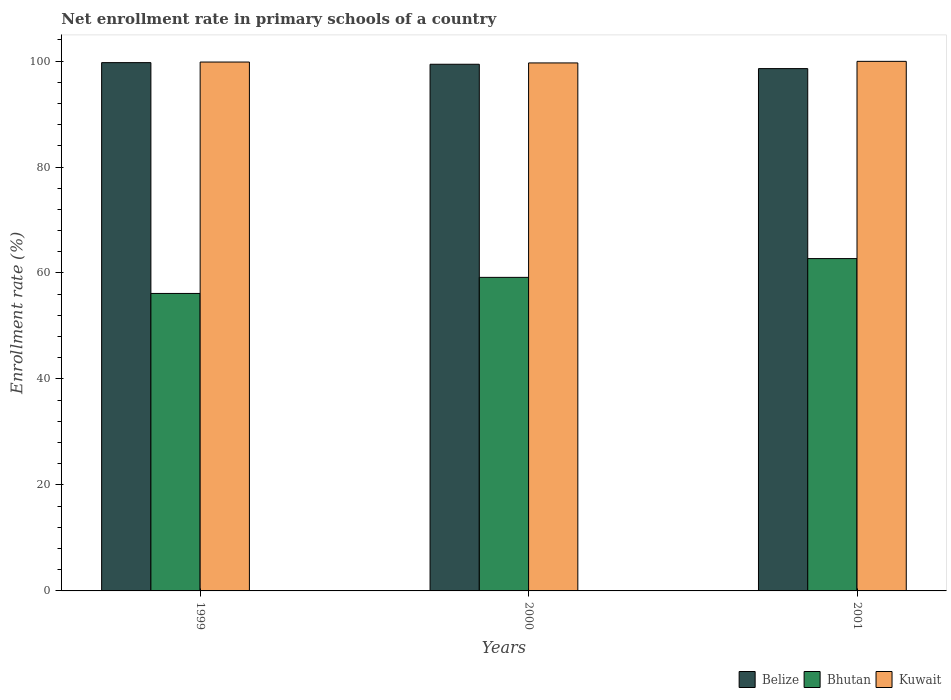How many different coloured bars are there?
Your answer should be very brief. 3. How many groups of bars are there?
Make the answer very short. 3. Are the number of bars on each tick of the X-axis equal?
Provide a succinct answer. Yes. In how many cases, is the number of bars for a given year not equal to the number of legend labels?
Provide a succinct answer. 0. What is the enrollment rate in primary schools in Kuwait in 2001?
Your answer should be very brief. 99.94. Across all years, what is the maximum enrollment rate in primary schools in Kuwait?
Make the answer very short. 99.94. Across all years, what is the minimum enrollment rate in primary schools in Belize?
Provide a succinct answer. 98.57. What is the total enrollment rate in primary schools in Bhutan in the graph?
Keep it short and to the point. 178.03. What is the difference between the enrollment rate in primary schools in Bhutan in 1999 and that in 2001?
Provide a succinct answer. -6.58. What is the difference between the enrollment rate in primary schools in Belize in 2001 and the enrollment rate in primary schools in Kuwait in 1999?
Your response must be concise. -1.24. What is the average enrollment rate in primary schools in Bhutan per year?
Offer a terse response. 59.34. In the year 2000, what is the difference between the enrollment rate in primary schools in Bhutan and enrollment rate in primary schools in Kuwait?
Ensure brevity in your answer.  -40.47. What is the ratio of the enrollment rate in primary schools in Belize in 1999 to that in 2001?
Provide a succinct answer. 1.01. Is the enrollment rate in primary schools in Bhutan in 1999 less than that in 2001?
Your answer should be compact. Yes. What is the difference between the highest and the second highest enrollment rate in primary schools in Bhutan?
Keep it short and to the point. 3.54. What is the difference between the highest and the lowest enrollment rate in primary schools in Kuwait?
Your response must be concise. 0.3. Is the sum of the enrollment rate in primary schools in Belize in 2000 and 2001 greater than the maximum enrollment rate in primary schools in Bhutan across all years?
Make the answer very short. Yes. What does the 2nd bar from the left in 2001 represents?
Offer a very short reply. Bhutan. What does the 2nd bar from the right in 2001 represents?
Your response must be concise. Bhutan. What is the difference between two consecutive major ticks on the Y-axis?
Offer a very short reply. 20. Are the values on the major ticks of Y-axis written in scientific E-notation?
Offer a terse response. No. Does the graph contain grids?
Your answer should be compact. No. How are the legend labels stacked?
Offer a terse response. Horizontal. What is the title of the graph?
Offer a very short reply. Net enrollment rate in primary schools of a country. Does "Middle income" appear as one of the legend labels in the graph?
Offer a very short reply. No. What is the label or title of the X-axis?
Offer a very short reply. Years. What is the label or title of the Y-axis?
Keep it short and to the point. Enrollment rate (%). What is the Enrollment rate (%) in Belize in 1999?
Ensure brevity in your answer.  99.7. What is the Enrollment rate (%) in Bhutan in 1999?
Your response must be concise. 56.14. What is the Enrollment rate (%) of Kuwait in 1999?
Your answer should be compact. 99.81. What is the Enrollment rate (%) of Belize in 2000?
Provide a short and direct response. 99.39. What is the Enrollment rate (%) in Bhutan in 2000?
Offer a terse response. 59.17. What is the Enrollment rate (%) in Kuwait in 2000?
Ensure brevity in your answer.  99.64. What is the Enrollment rate (%) in Belize in 2001?
Offer a terse response. 98.57. What is the Enrollment rate (%) of Bhutan in 2001?
Ensure brevity in your answer.  62.72. What is the Enrollment rate (%) in Kuwait in 2001?
Make the answer very short. 99.94. Across all years, what is the maximum Enrollment rate (%) of Belize?
Keep it short and to the point. 99.7. Across all years, what is the maximum Enrollment rate (%) in Bhutan?
Ensure brevity in your answer.  62.72. Across all years, what is the maximum Enrollment rate (%) in Kuwait?
Your response must be concise. 99.94. Across all years, what is the minimum Enrollment rate (%) in Belize?
Keep it short and to the point. 98.57. Across all years, what is the minimum Enrollment rate (%) in Bhutan?
Offer a terse response. 56.14. Across all years, what is the minimum Enrollment rate (%) in Kuwait?
Your answer should be compact. 99.64. What is the total Enrollment rate (%) in Belize in the graph?
Provide a succinct answer. 297.66. What is the total Enrollment rate (%) of Bhutan in the graph?
Keep it short and to the point. 178.03. What is the total Enrollment rate (%) of Kuwait in the graph?
Provide a succinct answer. 299.39. What is the difference between the Enrollment rate (%) in Belize in 1999 and that in 2000?
Your answer should be very brief. 0.31. What is the difference between the Enrollment rate (%) of Bhutan in 1999 and that in 2000?
Give a very brief answer. -3.04. What is the difference between the Enrollment rate (%) in Kuwait in 1999 and that in 2000?
Your answer should be compact. 0.17. What is the difference between the Enrollment rate (%) of Belize in 1999 and that in 2001?
Ensure brevity in your answer.  1.13. What is the difference between the Enrollment rate (%) of Bhutan in 1999 and that in 2001?
Your response must be concise. -6.58. What is the difference between the Enrollment rate (%) in Kuwait in 1999 and that in 2001?
Ensure brevity in your answer.  -0.13. What is the difference between the Enrollment rate (%) in Belize in 2000 and that in 2001?
Ensure brevity in your answer.  0.82. What is the difference between the Enrollment rate (%) of Bhutan in 2000 and that in 2001?
Give a very brief answer. -3.54. What is the difference between the Enrollment rate (%) in Kuwait in 2000 and that in 2001?
Ensure brevity in your answer.  -0.3. What is the difference between the Enrollment rate (%) in Belize in 1999 and the Enrollment rate (%) in Bhutan in 2000?
Keep it short and to the point. 40.52. What is the difference between the Enrollment rate (%) in Belize in 1999 and the Enrollment rate (%) in Kuwait in 2000?
Offer a terse response. 0.06. What is the difference between the Enrollment rate (%) of Bhutan in 1999 and the Enrollment rate (%) of Kuwait in 2000?
Offer a terse response. -43.5. What is the difference between the Enrollment rate (%) in Belize in 1999 and the Enrollment rate (%) in Bhutan in 2001?
Your response must be concise. 36.98. What is the difference between the Enrollment rate (%) in Belize in 1999 and the Enrollment rate (%) in Kuwait in 2001?
Your answer should be very brief. -0.24. What is the difference between the Enrollment rate (%) in Bhutan in 1999 and the Enrollment rate (%) in Kuwait in 2001?
Your response must be concise. -43.8. What is the difference between the Enrollment rate (%) in Belize in 2000 and the Enrollment rate (%) in Bhutan in 2001?
Provide a succinct answer. 36.67. What is the difference between the Enrollment rate (%) of Belize in 2000 and the Enrollment rate (%) of Kuwait in 2001?
Offer a very short reply. -0.55. What is the difference between the Enrollment rate (%) of Bhutan in 2000 and the Enrollment rate (%) of Kuwait in 2001?
Give a very brief answer. -40.77. What is the average Enrollment rate (%) of Belize per year?
Keep it short and to the point. 99.22. What is the average Enrollment rate (%) of Bhutan per year?
Provide a short and direct response. 59.34. What is the average Enrollment rate (%) of Kuwait per year?
Your answer should be compact. 99.8. In the year 1999, what is the difference between the Enrollment rate (%) in Belize and Enrollment rate (%) in Bhutan?
Offer a very short reply. 43.56. In the year 1999, what is the difference between the Enrollment rate (%) in Belize and Enrollment rate (%) in Kuwait?
Give a very brief answer. -0.11. In the year 1999, what is the difference between the Enrollment rate (%) in Bhutan and Enrollment rate (%) in Kuwait?
Ensure brevity in your answer.  -43.67. In the year 2000, what is the difference between the Enrollment rate (%) in Belize and Enrollment rate (%) in Bhutan?
Your answer should be very brief. 40.22. In the year 2000, what is the difference between the Enrollment rate (%) of Belize and Enrollment rate (%) of Kuwait?
Your response must be concise. -0.25. In the year 2000, what is the difference between the Enrollment rate (%) in Bhutan and Enrollment rate (%) in Kuwait?
Your answer should be compact. -40.47. In the year 2001, what is the difference between the Enrollment rate (%) of Belize and Enrollment rate (%) of Bhutan?
Keep it short and to the point. 35.85. In the year 2001, what is the difference between the Enrollment rate (%) in Belize and Enrollment rate (%) in Kuwait?
Give a very brief answer. -1.37. In the year 2001, what is the difference between the Enrollment rate (%) of Bhutan and Enrollment rate (%) of Kuwait?
Keep it short and to the point. -37.22. What is the ratio of the Enrollment rate (%) of Bhutan in 1999 to that in 2000?
Offer a very short reply. 0.95. What is the ratio of the Enrollment rate (%) in Kuwait in 1999 to that in 2000?
Ensure brevity in your answer.  1. What is the ratio of the Enrollment rate (%) in Belize in 1999 to that in 2001?
Your answer should be very brief. 1.01. What is the ratio of the Enrollment rate (%) of Bhutan in 1999 to that in 2001?
Your response must be concise. 0.9. What is the ratio of the Enrollment rate (%) of Kuwait in 1999 to that in 2001?
Offer a very short reply. 1. What is the ratio of the Enrollment rate (%) in Belize in 2000 to that in 2001?
Your answer should be very brief. 1.01. What is the ratio of the Enrollment rate (%) of Bhutan in 2000 to that in 2001?
Provide a succinct answer. 0.94. What is the ratio of the Enrollment rate (%) of Kuwait in 2000 to that in 2001?
Offer a very short reply. 1. What is the difference between the highest and the second highest Enrollment rate (%) of Belize?
Offer a very short reply. 0.31. What is the difference between the highest and the second highest Enrollment rate (%) of Bhutan?
Offer a very short reply. 3.54. What is the difference between the highest and the second highest Enrollment rate (%) in Kuwait?
Offer a very short reply. 0.13. What is the difference between the highest and the lowest Enrollment rate (%) in Belize?
Your answer should be very brief. 1.13. What is the difference between the highest and the lowest Enrollment rate (%) in Bhutan?
Make the answer very short. 6.58. What is the difference between the highest and the lowest Enrollment rate (%) of Kuwait?
Ensure brevity in your answer.  0.3. 